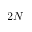<formula> <loc_0><loc_0><loc_500><loc_500>2 N</formula> 